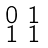<formula> <loc_0><loc_0><loc_500><loc_500>\begin{smallmatrix} 0 & 1 \\ 1 & 1 \end{smallmatrix}</formula> 